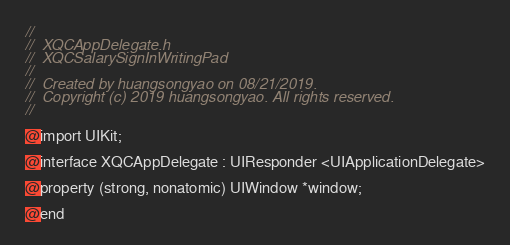<code> <loc_0><loc_0><loc_500><loc_500><_C_>//
//  XQCAppDelegate.h
//  XQCSalarySignInWritingPad
//
//  Created by huangsongyao on 08/21/2019.
//  Copyright (c) 2019 huangsongyao. All rights reserved.
//

@import UIKit;

@interface XQCAppDelegate : UIResponder <UIApplicationDelegate>

@property (strong, nonatomic) UIWindow *window;

@end
</code> 